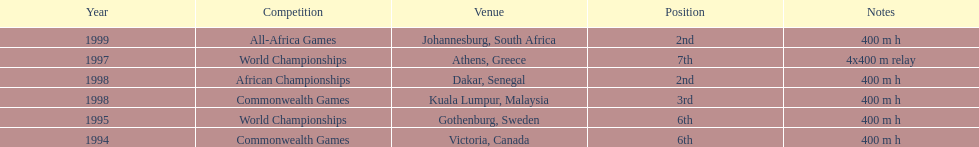What is the name of the last competition? All-Africa Games. 